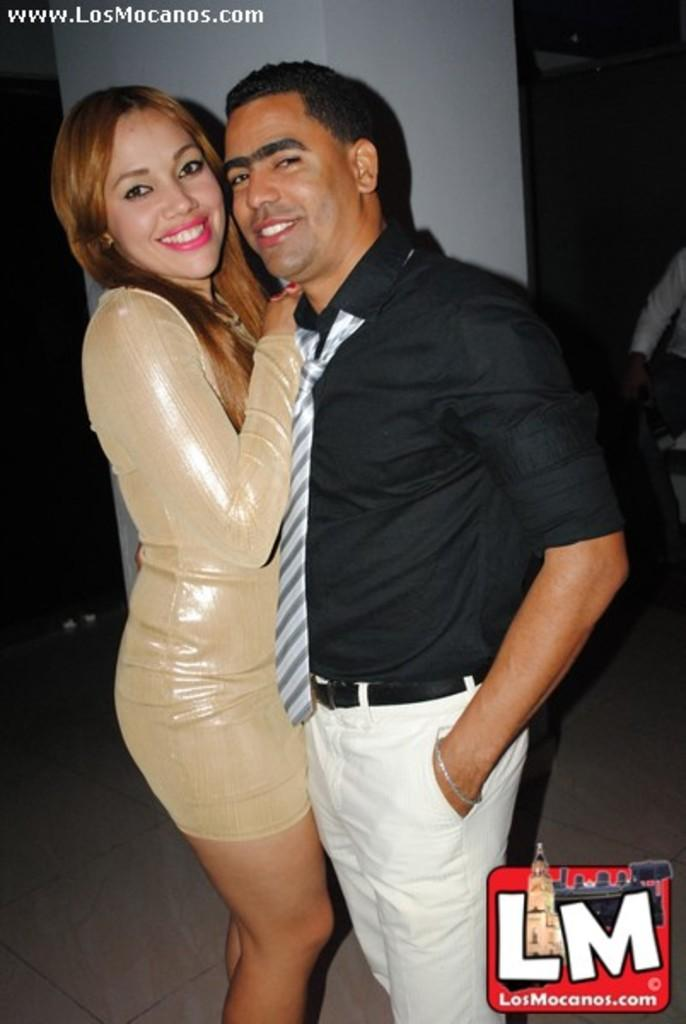How many people are in the image? There are two people in the image. What are the people doing in the image? The people are standing. What colors are the people wearing in the image? The people are wearing black, white, and cream-colored dresses. What is the color scheme of the background in the image? The background of the image is in white and black colors. What type of noise can be heard coming from the can in the image? There is no can present in the image, and therefore no noise can be heard coming from it. 